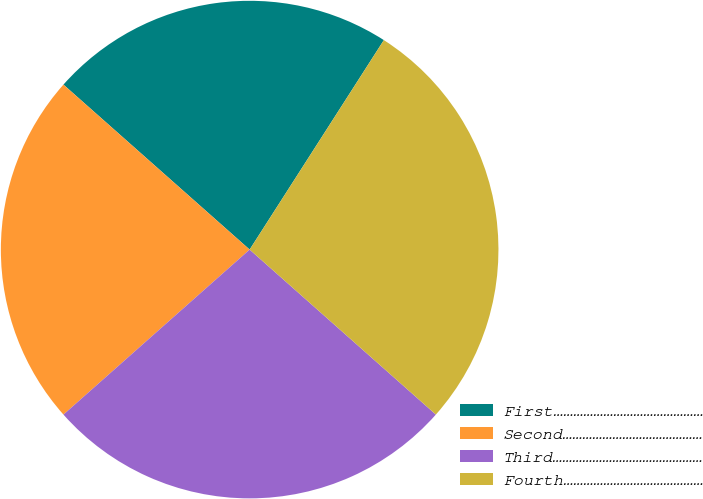Convert chart to OTSL. <chart><loc_0><loc_0><loc_500><loc_500><pie_chart><fcel>First………………………………………<fcel>Second……………………………………<fcel>Third………………………………………<fcel>Fourth……………………………………<nl><fcel>22.53%<fcel>23.08%<fcel>26.92%<fcel>27.47%<nl></chart> 